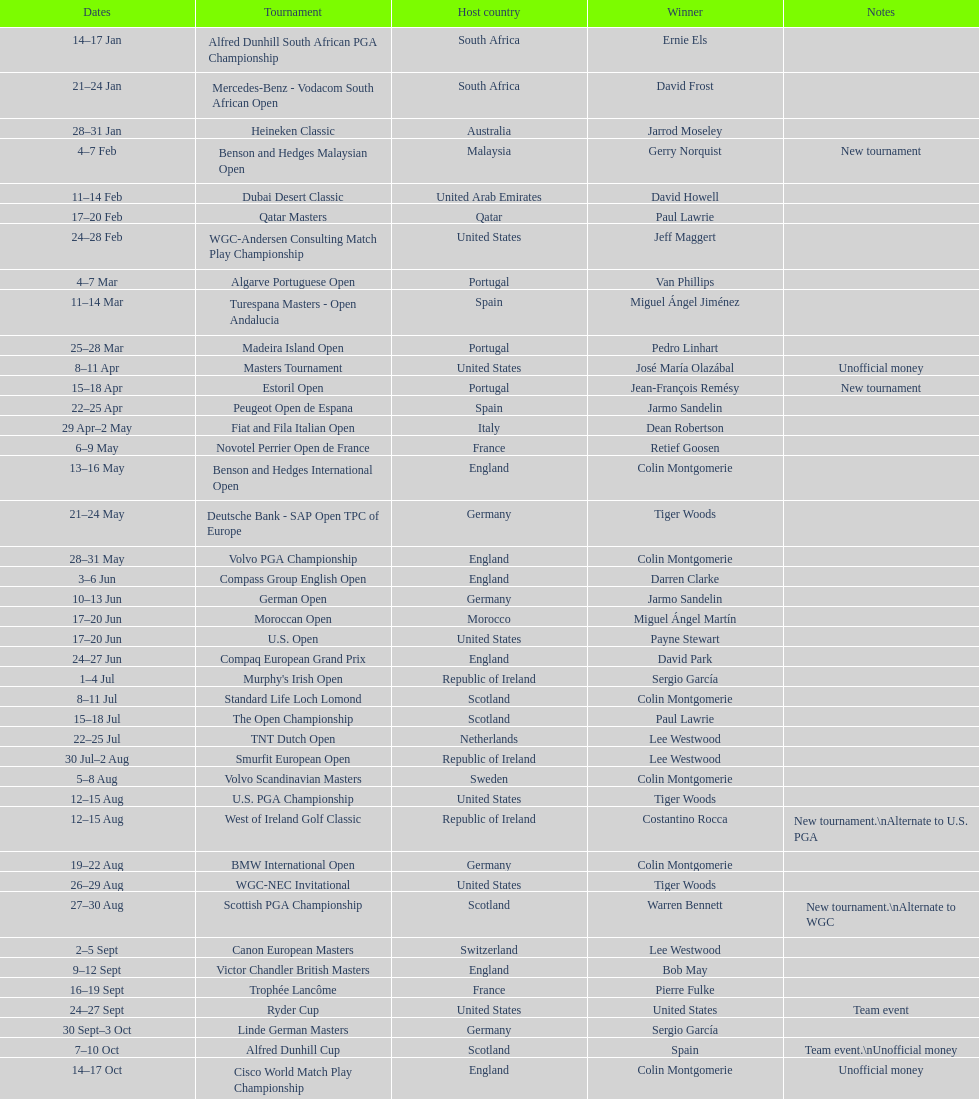How many consecutive times was south africa the host country? 2. 